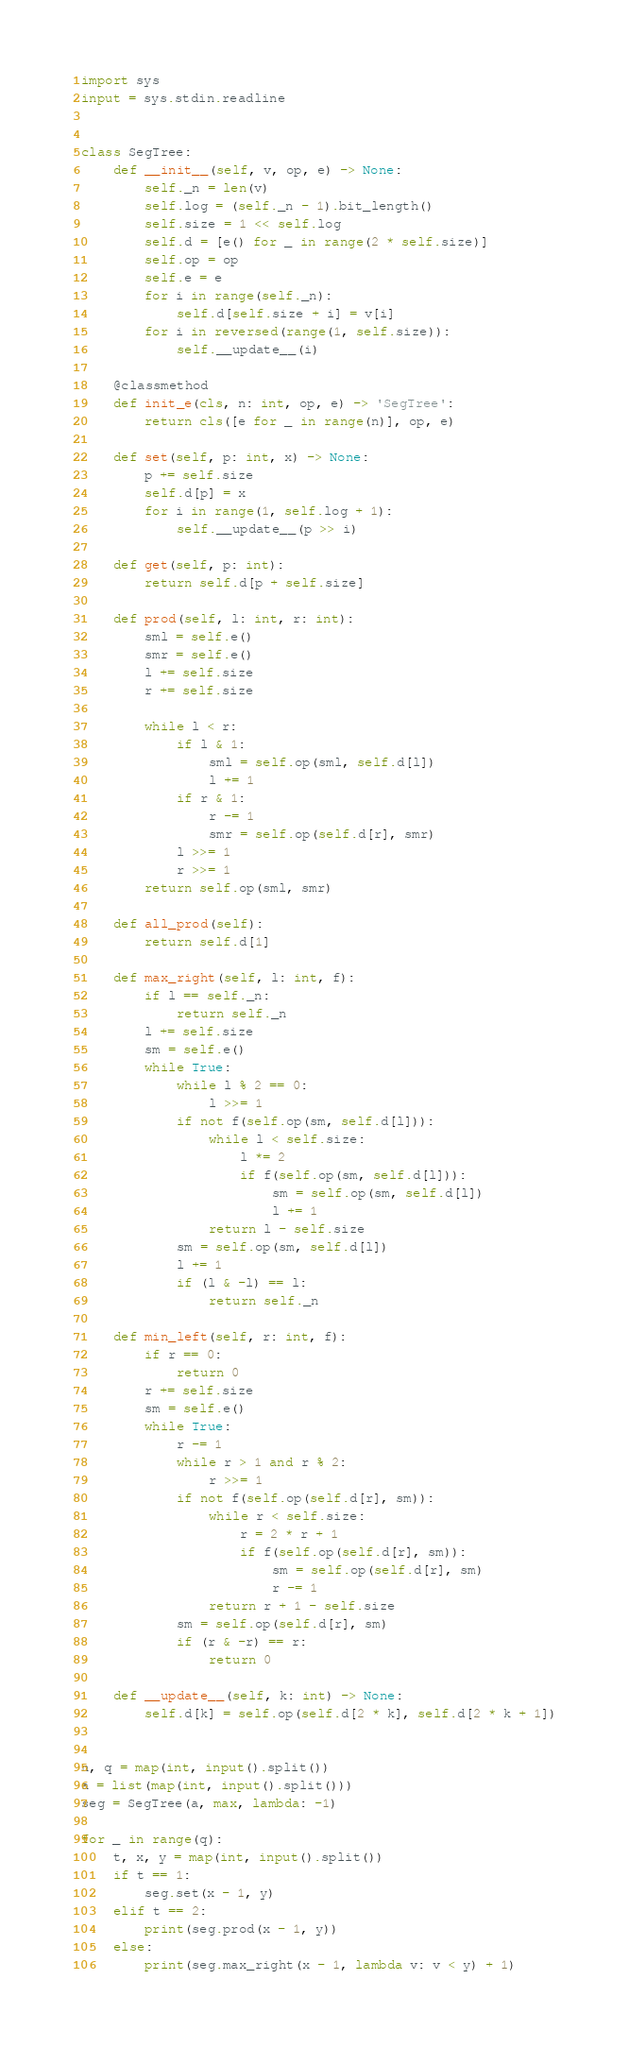<code> <loc_0><loc_0><loc_500><loc_500><_Python_>import sys
input = sys.stdin.readline


class SegTree:
    def __init__(self, v, op, e) -> None:
        self._n = len(v)
        self.log = (self._n - 1).bit_length()
        self.size = 1 << self.log
        self.d = [e() for _ in range(2 * self.size)]
        self.op = op
        self.e = e
        for i in range(self._n):
            self.d[self.size + i] = v[i]
        for i in reversed(range(1, self.size)):
            self.__update__(i)

    @classmethod
    def init_e(cls, n: int, op, e) -> 'SegTree':
        return cls([e for _ in range(n)], op, e)

    def set(self, p: int, x) -> None:
        p += self.size
        self.d[p] = x
        for i in range(1, self.log + 1):
            self.__update__(p >> i)

    def get(self, p: int):
        return self.d[p + self.size]

    def prod(self, l: int, r: int):
        sml = self.e()
        smr = self.e()
        l += self.size
        r += self.size

        while l < r:
            if l & 1:
                sml = self.op(sml, self.d[l])
                l += 1
            if r & 1:
                r -= 1
                smr = self.op(self.d[r], smr)
            l >>= 1
            r >>= 1
        return self.op(sml, smr)

    def all_prod(self):
        return self.d[1]

    def max_right(self, l: int, f):
        if l == self._n:
            return self._n
        l += self.size
        sm = self.e()
        while True:
            while l % 2 == 0:
                l >>= 1
            if not f(self.op(sm, self.d[l])):
                while l < self.size:
                    l *= 2
                    if f(self.op(sm, self.d[l])):
                        sm = self.op(sm, self.d[l])
                        l += 1
                return l - self.size
            sm = self.op(sm, self.d[l])
            l += 1
            if (l & -l) == l:
                return self._n

    def min_left(self, r: int, f):
        if r == 0:
            return 0
        r += self.size
        sm = self.e()
        while True:
            r -= 1
            while r > 1 and r % 2:
                r >>= 1
            if not f(self.op(self.d[r], sm)):
                while r < self.size:
                    r = 2 * r + 1
                    if f(self.op(self.d[r], sm)):
                        sm = self.op(self.d[r], sm)
                        r -= 1
                return r + 1 - self.size
            sm = self.op(self.d[r], sm)
            if (r & -r) == r:
                return 0

    def __update__(self, k: int) -> None:
        self.d[k] = self.op(self.d[2 * k], self.d[2 * k + 1])


n, q = map(int, input().split())
a = list(map(int, input().split()))
seg = SegTree(a, max, lambda: -1)

for _ in range(q):
    t, x, y = map(int, input().split())
    if t == 1:
        seg.set(x - 1, y)
    elif t == 2:
        print(seg.prod(x - 1, y))
    else:
        print(seg.max_right(x - 1, lambda v: v < y) + 1)
</code> 